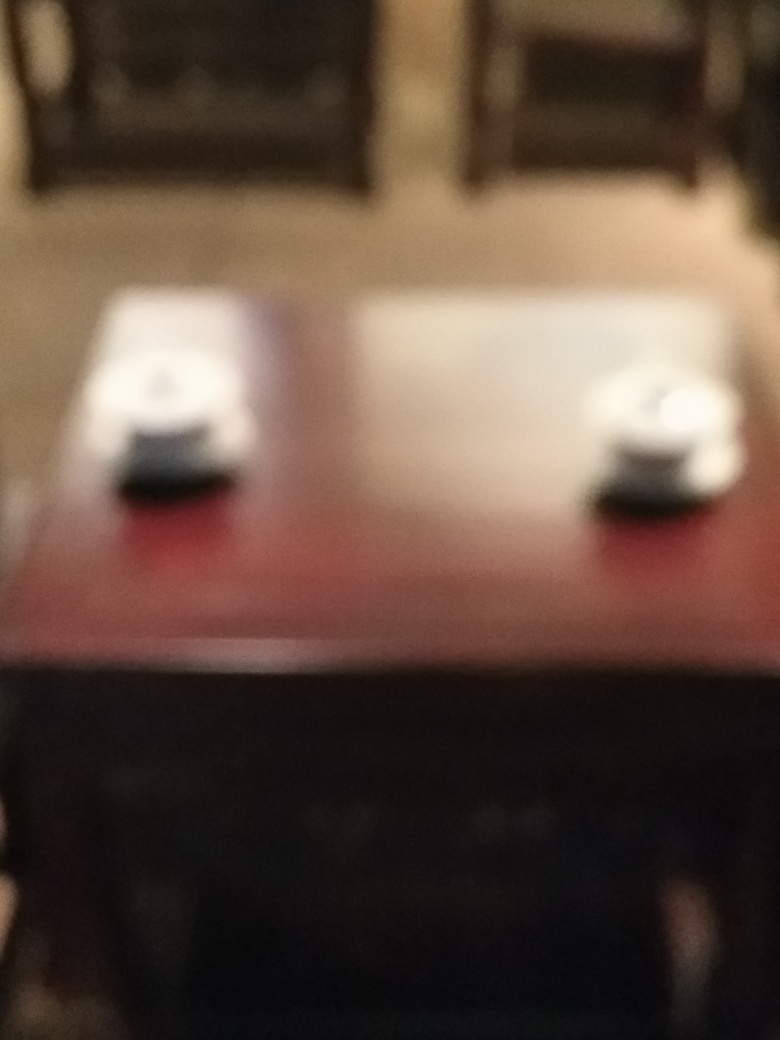Could this image be artistically valuable despite its lack of focus? Absolutely, art is subjective, and sometimes an out-of-focus image can convey emotions or concepts that a sharp image might not. The blur may intentionally represent memory, a dream state, or the passage of time, leaving much to the viewer's interpretation. 